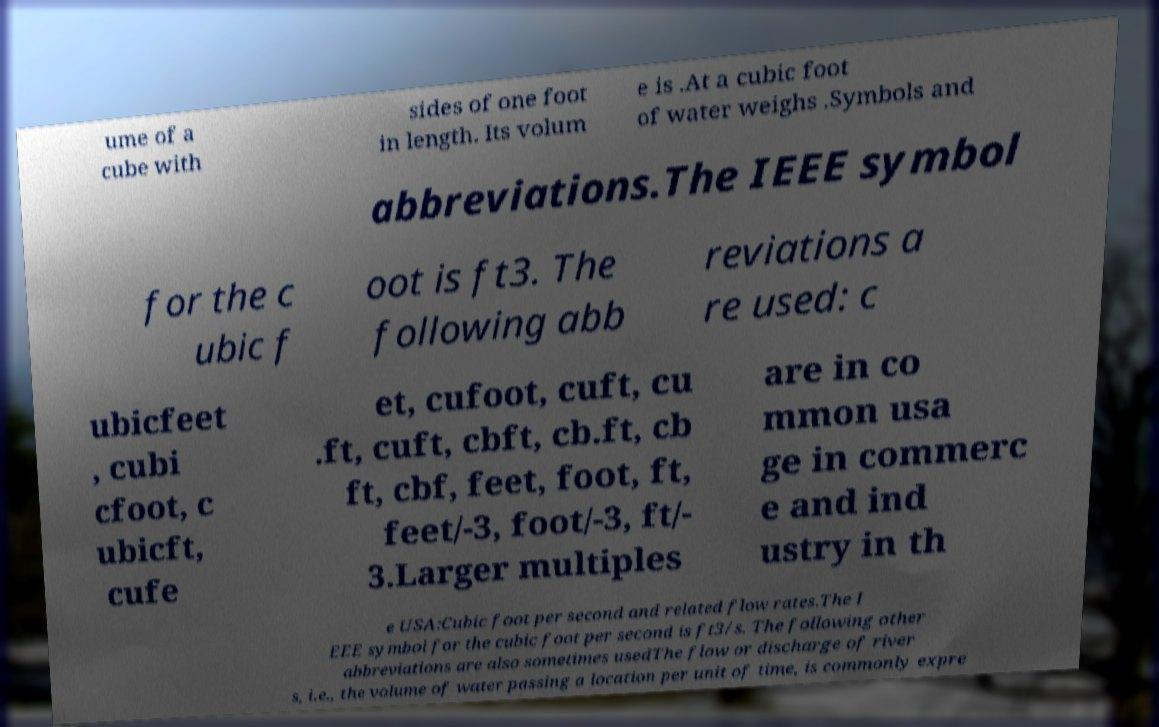Can you read and provide the text displayed in the image?This photo seems to have some interesting text. Can you extract and type it out for me? ume of a cube with sides of one foot in length. Its volum e is .At a cubic foot of water weighs .Symbols and abbreviations.The IEEE symbol for the c ubic f oot is ft3. The following abb reviations a re used: c ubicfeet , cubi cfoot, c ubicft, cufe et, cufoot, cuft, cu .ft, cuft, cbft, cb.ft, cb ft, cbf, feet, foot, ft, feet/-3, foot/-3, ft/- 3.Larger multiples are in co mmon usa ge in commerc e and ind ustry in th e USA:Cubic foot per second and related flow rates.The I EEE symbol for the cubic foot per second is ft3/s. The following other abbreviations are also sometimes usedThe flow or discharge of river s, i.e., the volume of water passing a location per unit of time, is commonly expre 